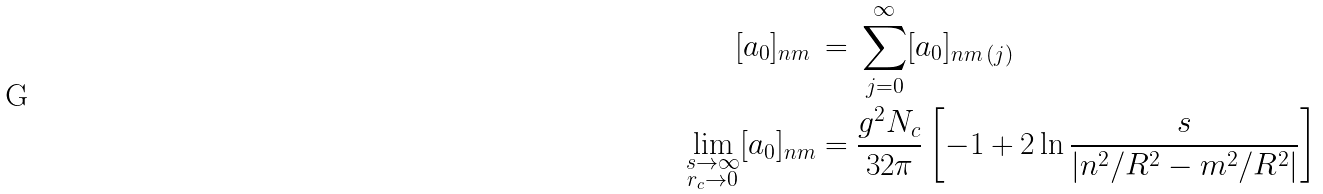Convert formula to latex. <formula><loc_0><loc_0><loc_500><loc_500>[ a _ { 0 } ] _ { n m } \, & = \, \sum _ { j = 0 } ^ { \infty } [ a _ { 0 } ] _ { n m \, ( j ) } \\ \lim _ { \substack { s \to \infty \\ r _ { c } \to 0 } } [ a _ { 0 } ] _ { n m } & = \frac { g ^ { 2 } N _ { c } } { 3 2 \pi } \left [ - 1 + 2 \ln \frac { s } { | n ^ { 2 } / R ^ { 2 } - m ^ { 2 } / R ^ { 2 } | } \right ]</formula> 